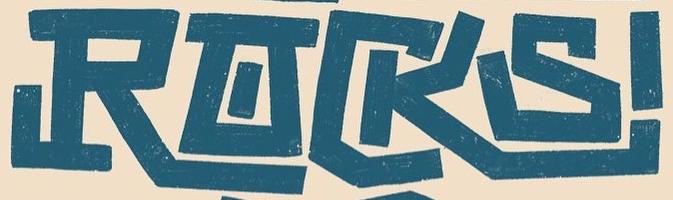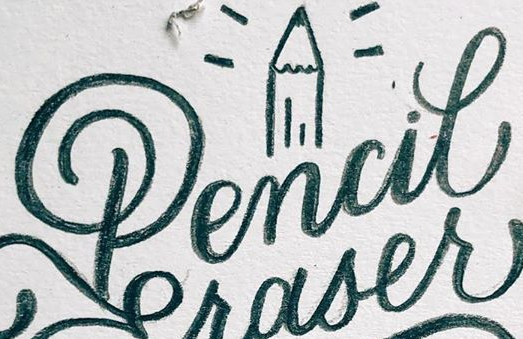Read the text from these images in sequence, separated by a semicolon. RACKS; Pencil 